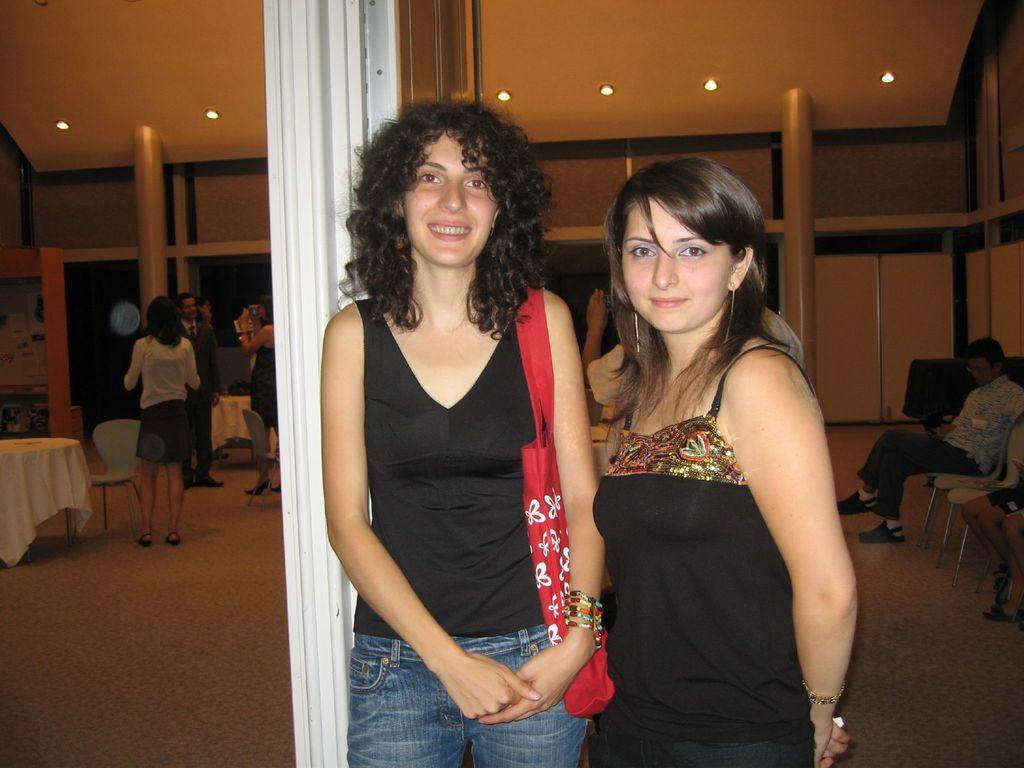Describe this image in one or two sentences. In the picture I can see people, among them one person is sitting on a chair and others are standing on the floor. In the background I can see poles, lights on the ceiling, wall, tables which are covered with white color clothes, chairs and some other things. 